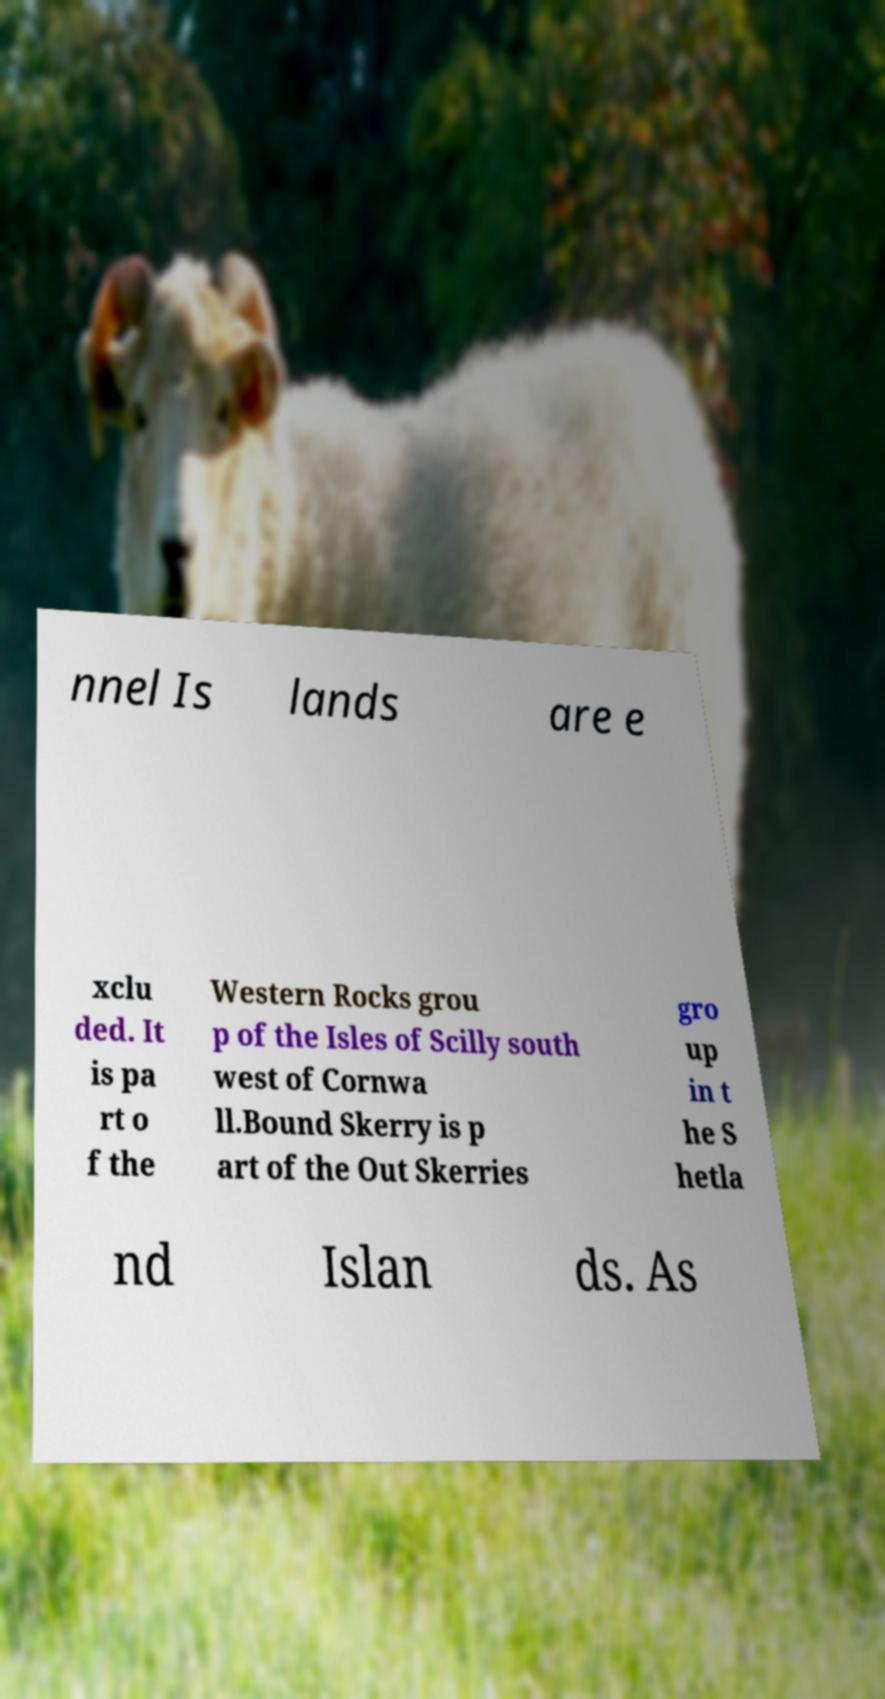For documentation purposes, I need the text within this image transcribed. Could you provide that? nnel Is lands are e xclu ded. It is pa rt o f the Western Rocks grou p of the Isles of Scilly south west of Cornwa ll.Bound Skerry is p art of the Out Skerries gro up in t he S hetla nd Islan ds. As 